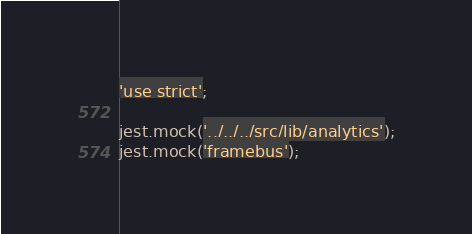<code> <loc_0><loc_0><loc_500><loc_500><_JavaScript_>'use strict';

jest.mock('../../../src/lib/analytics');
jest.mock('framebus');
</code> 